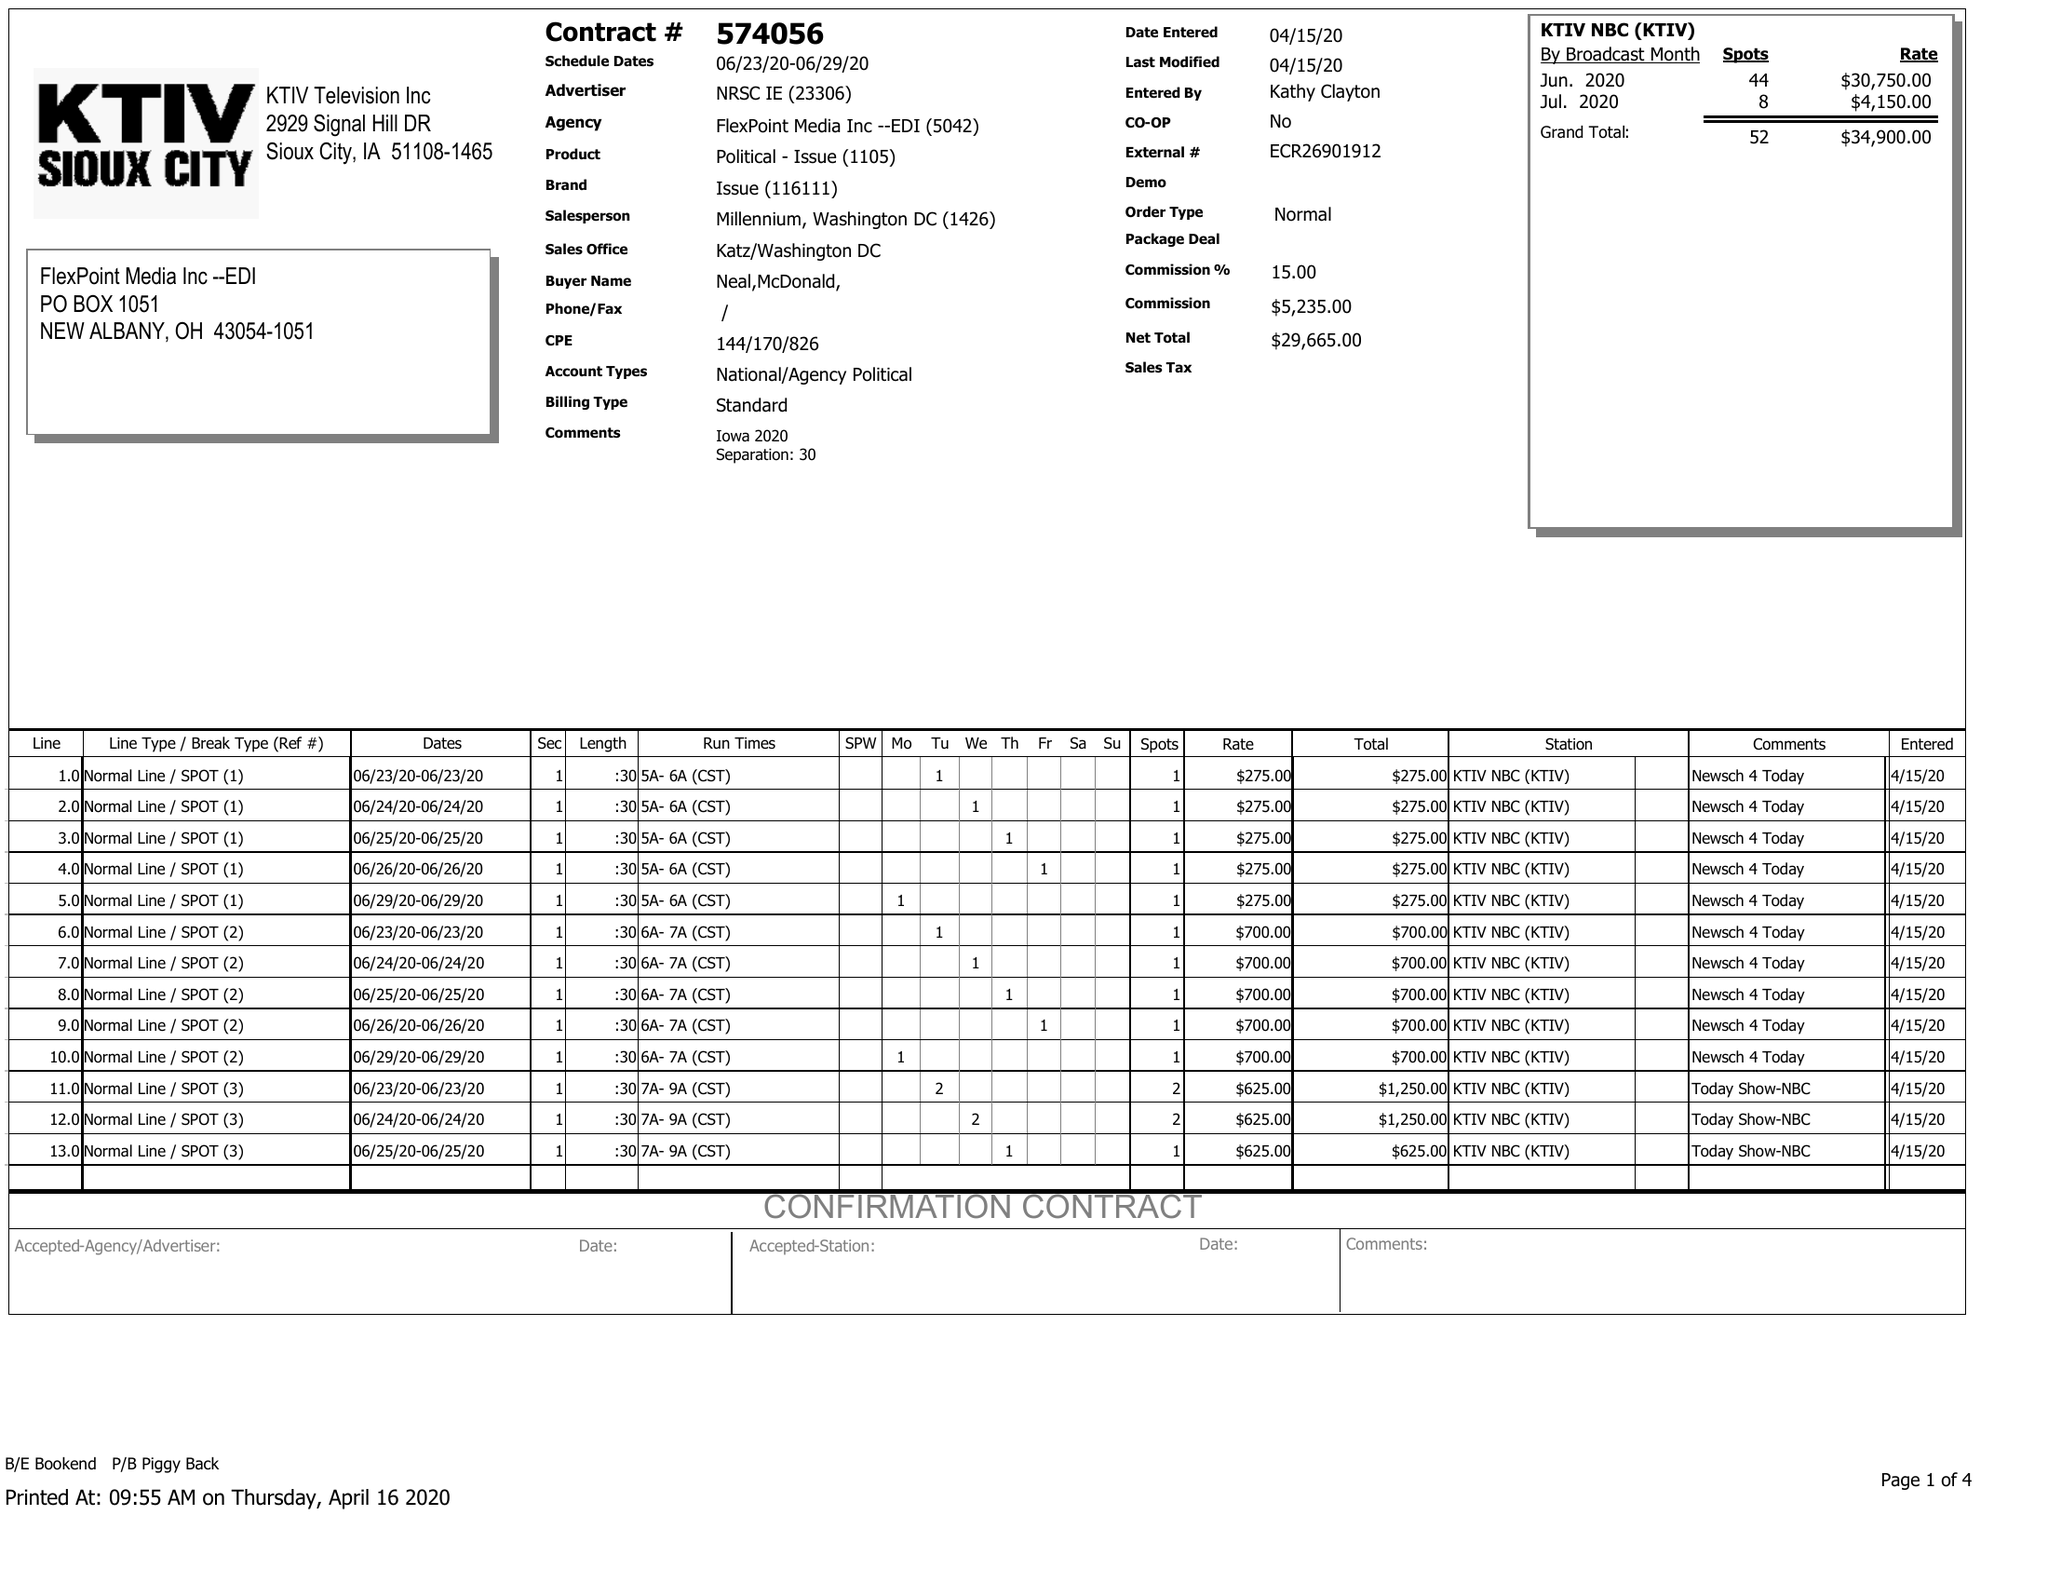What is the value for the gross_amount?
Answer the question using a single word or phrase. 34900.00 